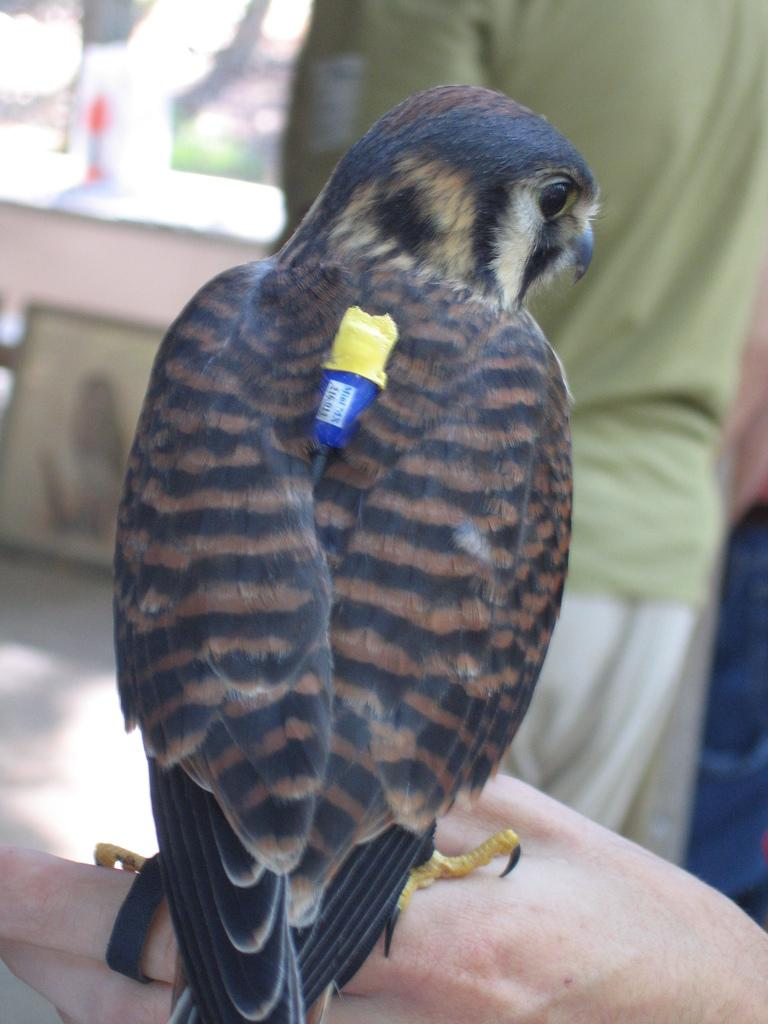What is the main subject in the middle of the image? There is a bird in the middle of the image. Can you describe the background of the image? There are people in the background of the image. What type of crown is the bird wearing in the image? There is no crown present in the image; the bird is not wearing anything. 